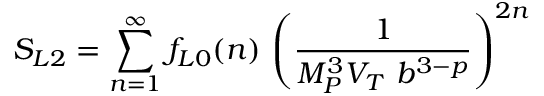Convert formula to latex. <formula><loc_0><loc_0><loc_500><loc_500>S _ { L 2 } = \sum _ { n = 1 } ^ { \infty } f _ { L 0 } ( n ) \, \left ( { \frac { 1 } { M _ { P } ^ { 3 } V _ { T } b ^ { 3 - p } } } \right ) ^ { 2 n }</formula> 